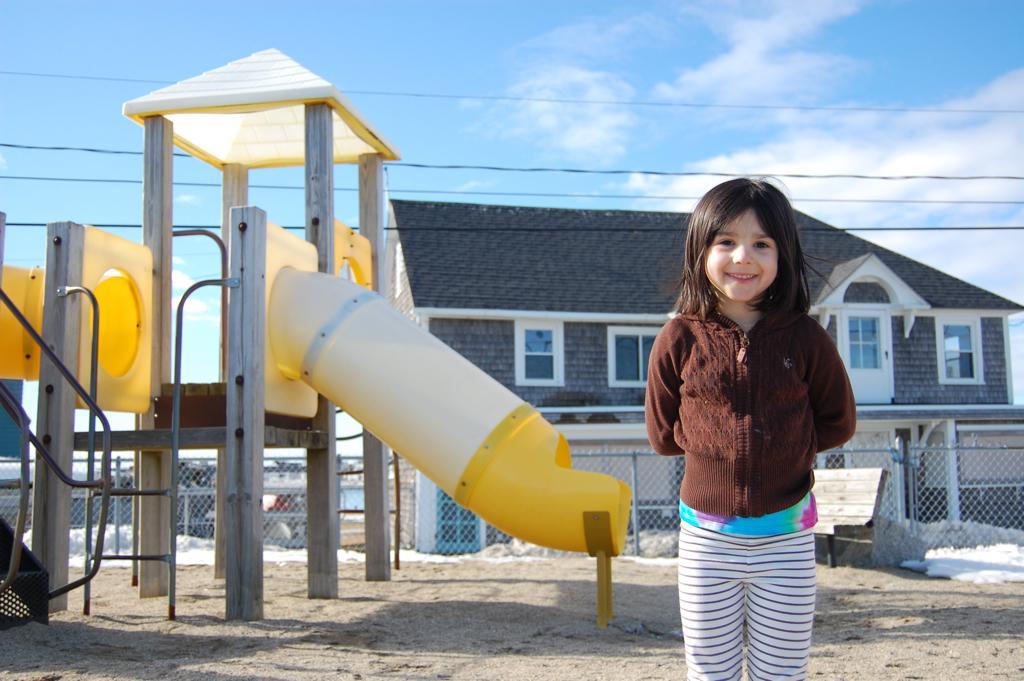Please provide a concise description of this image. In this image there is a girl standing on a ground, on the left side there is a playground slide, in the background there is fencing, house, wires and the sky. 